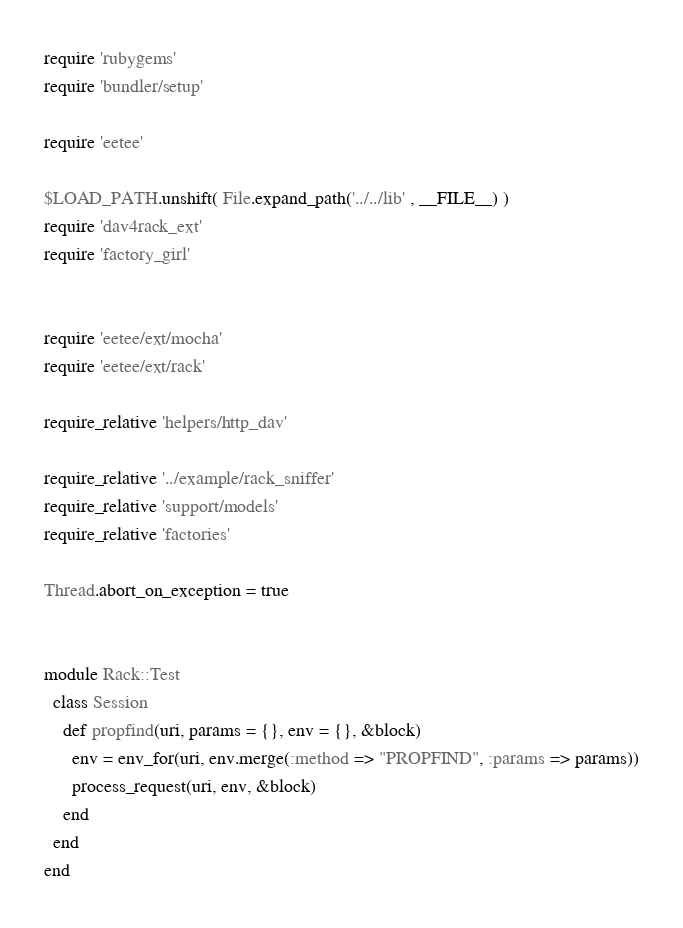Convert code to text. <code><loc_0><loc_0><loc_500><loc_500><_Ruby_>require 'rubygems'
require 'bundler/setup'

require 'eetee'

$LOAD_PATH.unshift( File.expand_path('../../lib' , __FILE__) )
require 'dav4rack_ext'
require 'factory_girl'


require 'eetee/ext/mocha'
require 'eetee/ext/rack'

require_relative 'helpers/http_dav'

require_relative '../example/rack_sniffer'
require_relative 'support/models'
require_relative 'factories'

Thread.abort_on_exception = true


module Rack::Test
  class Session
    def propfind(uri, params = {}, env = {}, &block)
      env = env_for(uri, env.merge(:method => "PROPFIND", :params => params))
      process_request(uri, env, &block)
    end
  end
end



</code> 